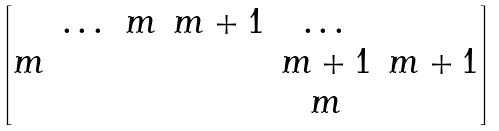<formula> <loc_0><loc_0><loc_500><loc_500>\begin{bmatrix} & \dots & m & m + 1 & \dots & \\ m & & & & m + 1 & m + 1 \\ & & & & m & \end{bmatrix}</formula> 